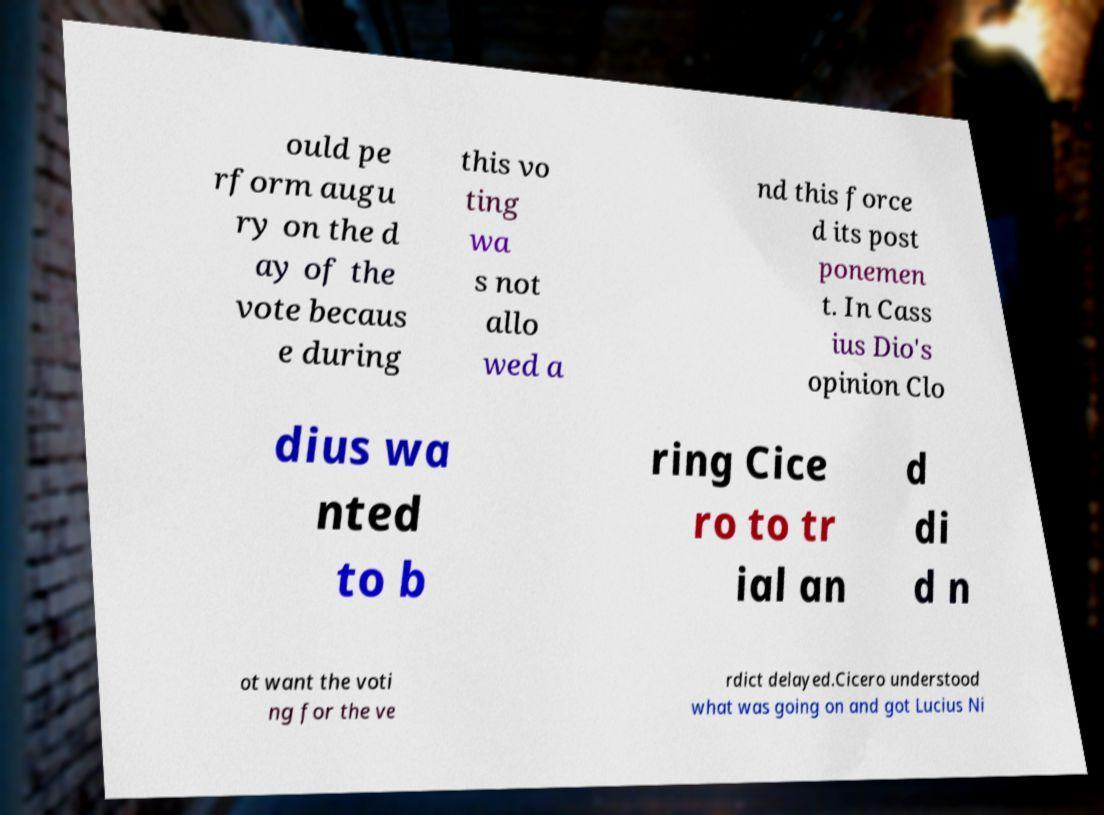Please read and relay the text visible in this image. What does it say? ould pe rform augu ry on the d ay of the vote becaus e during this vo ting wa s not allo wed a nd this force d its post ponemen t. In Cass ius Dio's opinion Clo dius wa nted to b ring Cice ro to tr ial an d di d n ot want the voti ng for the ve rdict delayed.Cicero understood what was going on and got Lucius Ni 